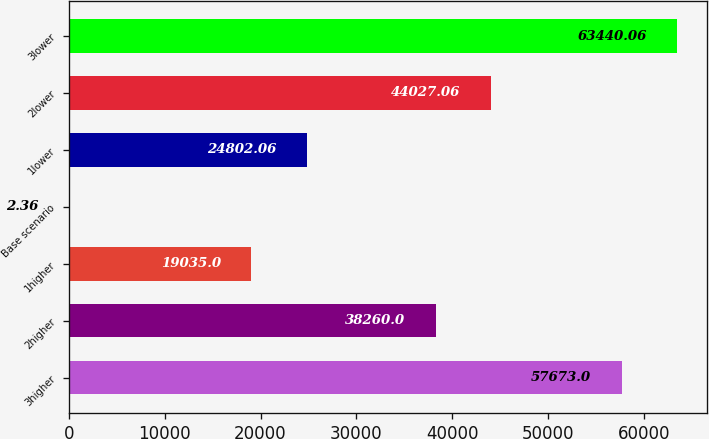<chart> <loc_0><loc_0><loc_500><loc_500><bar_chart><fcel>3higher<fcel>2higher<fcel>1higher<fcel>Base scenario<fcel>1lower<fcel>2lower<fcel>3lower<nl><fcel>57673<fcel>38260<fcel>19035<fcel>2.36<fcel>24802.1<fcel>44027.1<fcel>63440.1<nl></chart> 